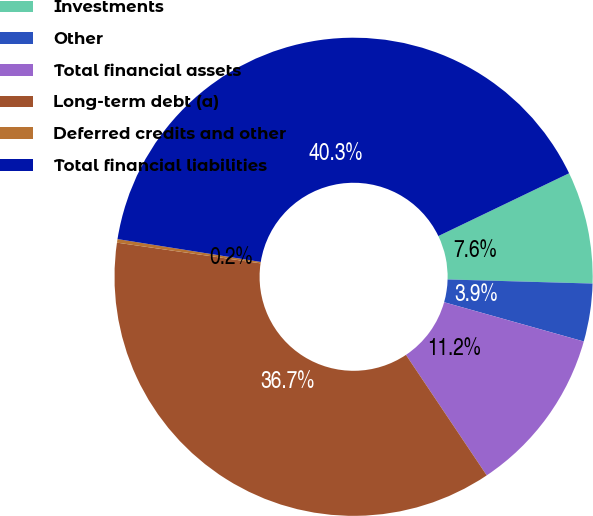Convert chart to OTSL. <chart><loc_0><loc_0><loc_500><loc_500><pie_chart><fcel>Investments<fcel>Other<fcel>Total financial assets<fcel>Long-term debt (a)<fcel>Deferred credits and other<fcel>Total financial liabilities<nl><fcel>7.58%<fcel>3.91%<fcel>11.24%<fcel>36.68%<fcel>0.24%<fcel>40.35%<nl></chart> 